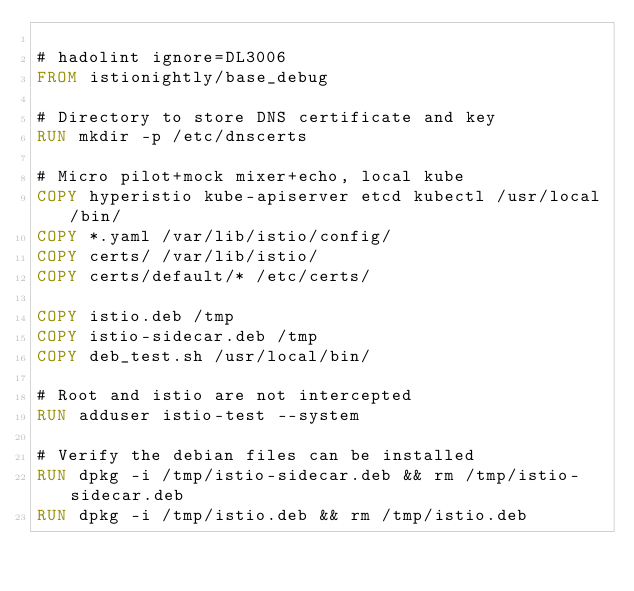<code> <loc_0><loc_0><loc_500><loc_500><_Dockerfile_>
# hadolint ignore=DL3006
FROM istionightly/base_debug

# Directory to store DNS certificate and key
RUN mkdir -p /etc/dnscerts

# Micro pilot+mock mixer+echo, local kube
COPY hyperistio kube-apiserver etcd kubectl /usr/local/bin/
COPY *.yaml /var/lib/istio/config/
COPY certs/ /var/lib/istio/
COPY certs/default/* /etc/certs/

COPY istio.deb /tmp
COPY istio-sidecar.deb /tmp
COPY deb_test.sh /usr/local/bin/

# Root and istio are not intercepted
RUN adduser istio-test --system

# Verify the debian files can be installed
RUN dpkg -i /tmp/istio-sidecar.deb && rm /tmp/istio-sidecar.deb
RUN dpkg -i /tmp/istio.deb && rm /tmp/istio.deb

</code> 